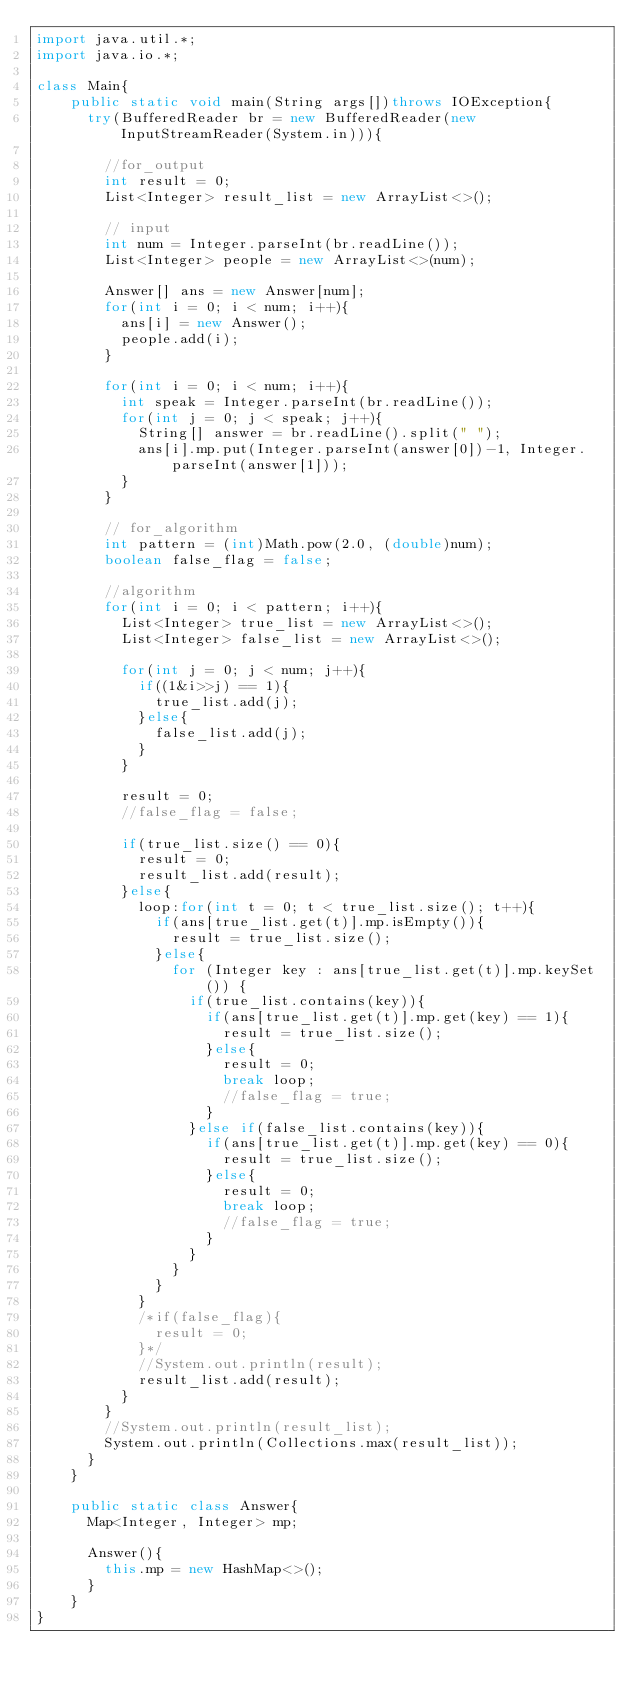<code> <loc_0><loc_0><loc_500><loc_500><_Java_>import java.util.*;
import java.io.*;

class Main{
    public static void main(String args[])throws IOException{
      try(BufferedReader br = new BufferedReader(new InputStreamReader(System.in))){
      
        //for_output
        int result = 0;
        List<Integer> result_list = new ArrayList<>();

        // input
        int num = Integer.parseInt(br.readLine());
        List<Integer> people = new ArrayList<>(num);

        Answer[] ans = new Answer[num];
        for(int i = 0; i < num; i++){
          ans[i] = new Answer();
          people.add(i);
        }

        for(int i = 0; i < num; i++){
          int speak = Integer.parseInt(br.readLine());
          for(int j = 0; j < speak; j++){
            String[] answer = br.readLine().split(" ");
            ans[i].mp.put(Integer.parseInt(answer[0])-1, Integer.parseInt(answer[1]));
          }  
        }

        // for_algorithm
        int pattern = (int)Math.pow(2.0, (double)num);
        boolean false_flag = false;

        //algorithm
        for(int i = 0; i < pattern; i++){
          List<Integer> true_list = new ArrayList<>();
          List<Integer> false_list = new ArrayList<>();
 
          for(int j = 0; j < num; j++){
            if((1&i>>j) == 1){
              true_list.add(j);
            }else{
              false_list.add(j);
            }
          }

          result = 0;
          //false_flag = false;

          if(true_list.size() == 0){
            result = 0;
            result_list.add(result);
          }else{
            loop:for(int t = 0; t < true_list.size(); t++){
              if(ans[true_list.get(t)].mp.isEmpty()){
                result = true_list.size();
              }else{
                for (Integer key : ans[true_list.get(t)].mp.keySet()) {
                  if(true_list.contains(key)){
                    if(ans[true_list.get(t)].mp.get(key) == 1){
                      result = true_list.size();
                    }else{
                      result = 0;
                      break loop;
                      //false_flag = true;
                    }
                  }else if(false_list.contains(key)){
                    if(ans[true_list.get(t)].mp.get(key) == 0){
                      result = true_list.size();
                    }else{
                      result = 0;
                      break loop;
                      //false_flag = true;
                    }
                  }
                }
              }
            }
            /*if(false_flag){
              result = 0;
            }*/
            //System.out.println(result);
            result_list.add(result);
          }
        }
        //System.out.println(result_list);
        System.out.println(Collections.max(result_list));
      }
    }

    public static class Answer{
      Map<Integer, Integer> mp;

      Answer(){
        this.mp = new HashMap<>();
      }
    } 
}
</code> 